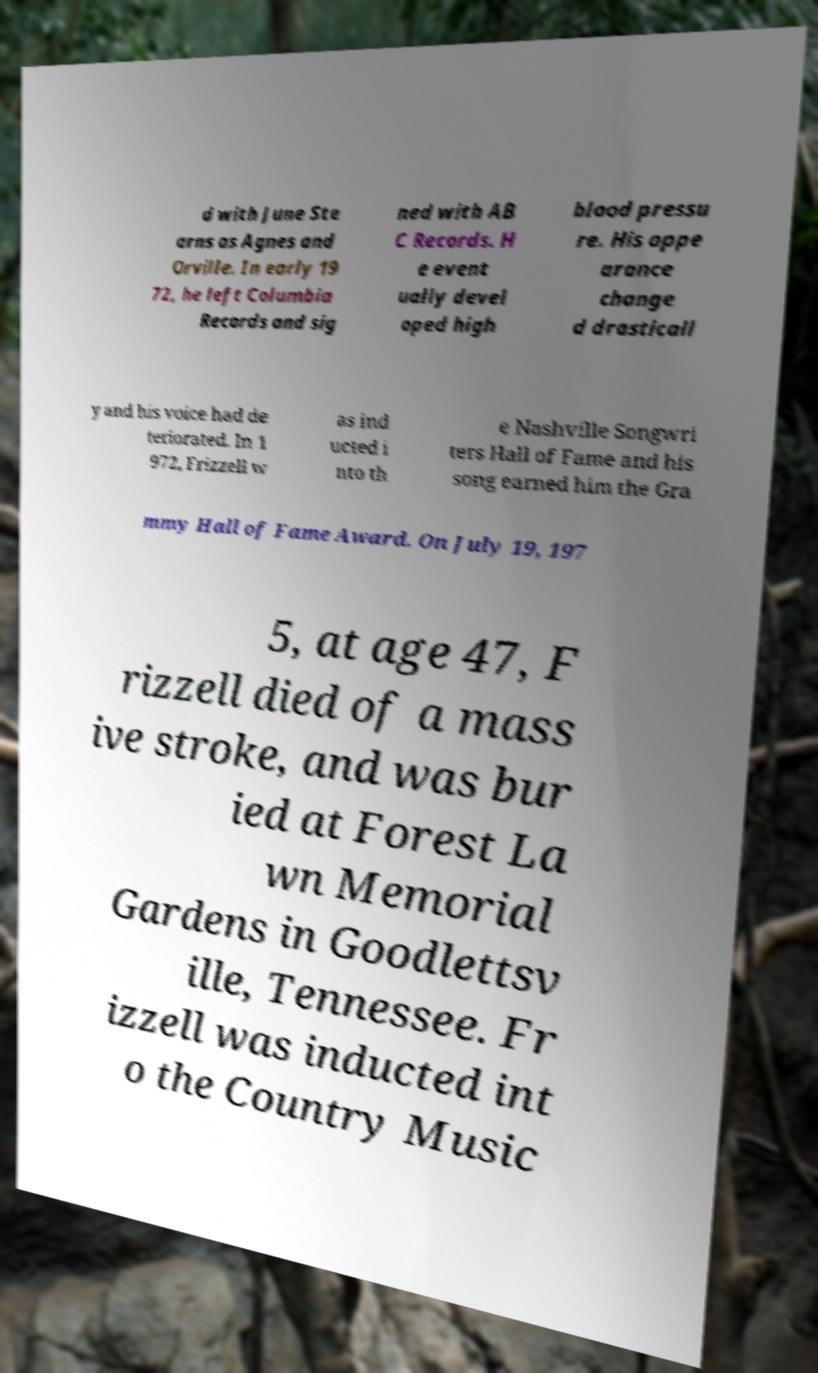There's text embedded in this image that I need extracted. Can you transcribe it verbatim? d with June Ste arns as Agnes and Orville. In early 19 72, he left Columbia Records and sig ned with AB C Records. H e event ually devel oped high blood pressu re. His appe arance change d drasticall y and his voice had de teriorated. In 1 972, Frizzell w as ind ucted i nto th e Nashville Songwri ters Hall of Fame and his song earned him the Gra mmy Hall of Fame Award. On July 19, 197 5, at age 47, F rizzell died of a mass ive stroke, and was bur ied at Forest La wn Memorial Gardens in Goodlettsv ille, Tennessee. Fr izzell was inducted int o the Country Music 